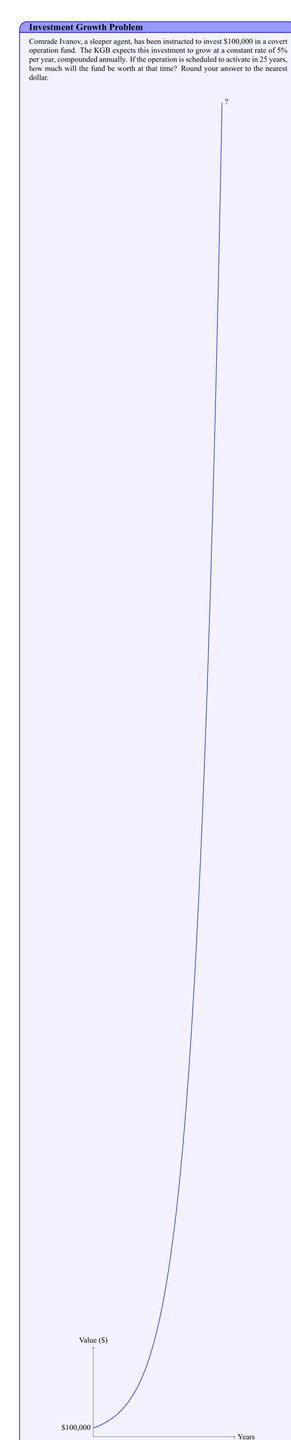Can you answer this question? To solve this problem, we'll use the compound interest formula:

$$A = P(1 + r)^n$$

Where:
$A$ = Final amount
$P$ = Principal (initial investment)
$r$ = Annual interest rate (as a decimal)
$n$ = Number of years

Given:
$P = 100,000$
$r = 0.05$ (5% expressed as a decimal)
$n = 25$ years

Let's substitute these values into the formula:

$$A = 100,000(1 + 0.05)^{25}$$

Now, let's calculate step-by-step:

1) First, calculate $(1 + 0.05)^{25}$:
   $$(1.05)^{25} \approx 3.3863827...$$

2) Multiply this by the principal:
   $$100,000 \times 3.3863827... \approx 338,638.27...$$

3) Rounding to the nearest dollar:
   $$338,638$$

Therefore, after 25 years, the sleeper agent's fund will be worth $338,638.
Answer: $338,638 